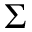<formula> <loc_0><loc_0><loc_500><loc_500>\Sigma</formula> 